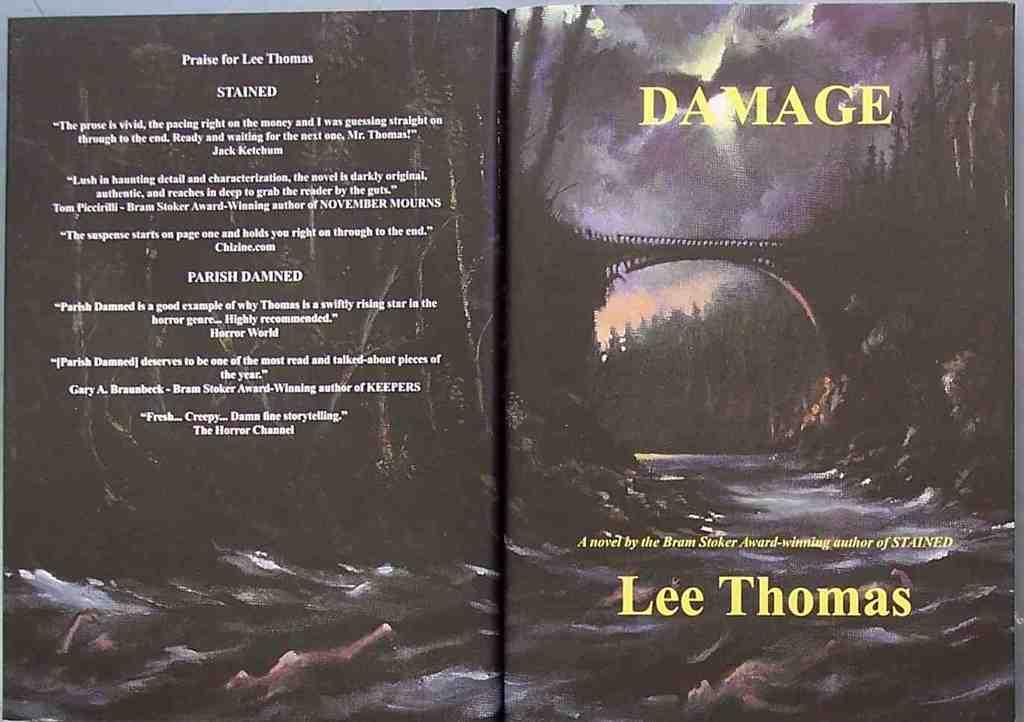Provide a one-sentence caption for the provided image. A book titled Damage by lee Thomas features a spooky cover of a bridge and river during a storm. 